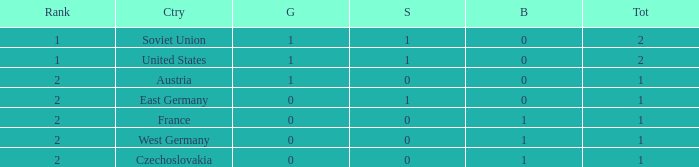What is the total count of bronze medals for west germany, which holds a rank of 2 and has fewer than 1 total medals? 0.0. 